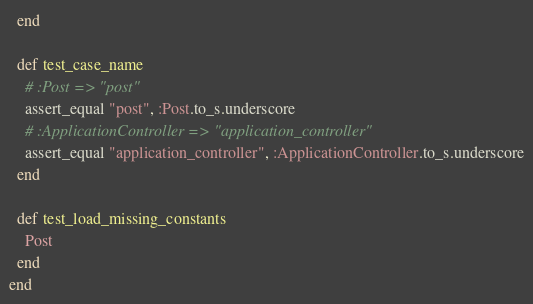Convert code to text. <code><loc_0><loc_0><loc_500><loc_500><_Ruby_>  end

  def test_case_name
    # :Post => "post"
    assert_equal "post", :Post.to_s.underscore
    # :ApplicationController => "application_controller"
    assert_equal "application_controller", :ApplicationController.to_s.underscore
  end

  def test_load_missing_constants
    Post
  end
end</code> 